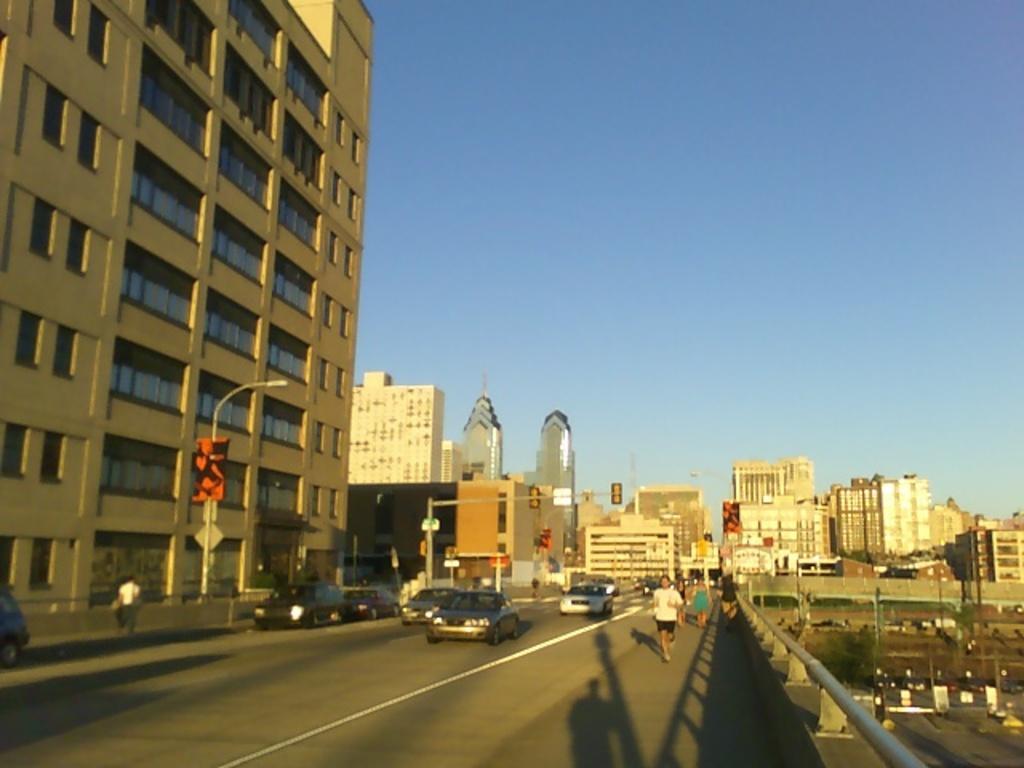How would you summarize this image in a sentence or two? There are vehicles and few persons on the road. Here we can see poles, boards, and buildings. In the background there is sky. 